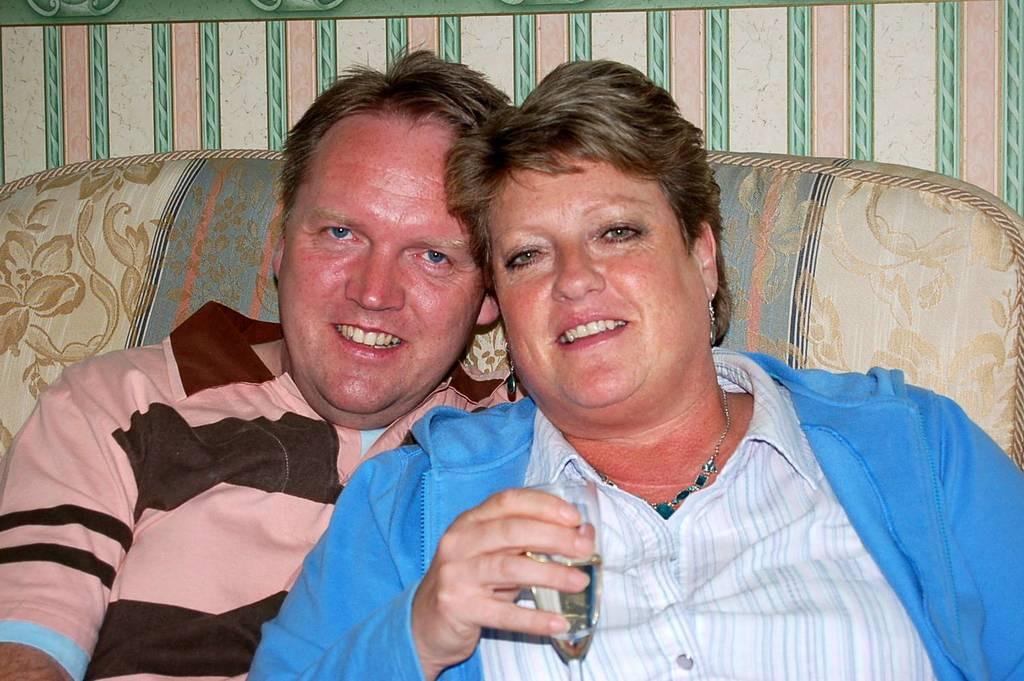What is the woman in the image holding? The woman is holding a glass. Who else is present in the image? There is a man in the image. What is the man doing in the image? The man is sitting on a sofa and looking and smiling at someone. What type of organization is the man a part of in the image? There is no information about any organization in the image; it only shows a woman holding a glass and a man sitting on a sofa. How many brothers does the woman have in the image? There is no information about any brothers in the image; it only shows a woman holding a glass and a man sitting on a sofa. 